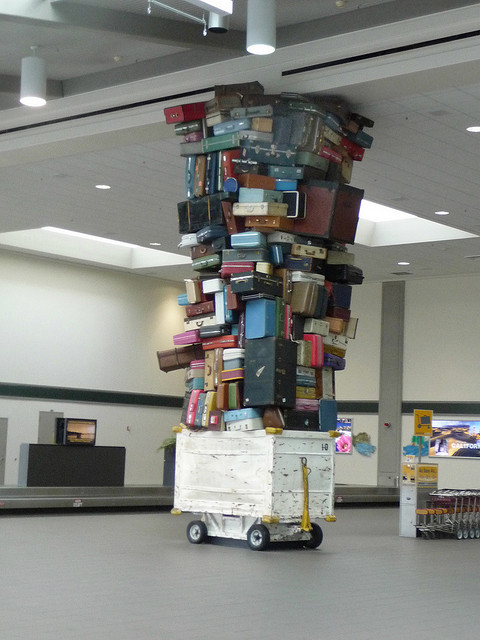Can you guess where this photo might have been taken? Although I cannot pinpoint the exact location, this image is likely taken at an airport or a travel hub, given the context of luggage and the interior design that resembles a terminal or waiting area. Such installations are often found in airports to entertain, distract, or engage passengers as they pass through. 